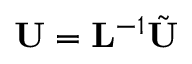<formula> <loc_0><loc_0><loc_500><loc_500>{ U } = { L } ^ { - 1 } \tilde { U }</formula> 